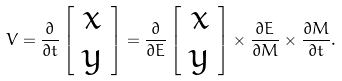<formula> <loc_0><loc_0><loc_500><loc_500>V = \frac { \partial } { \partial t } \left [ \begin{array} { c } x \\ y \end{array} \right ] = \frac { \partial } { \partial E } \left [ \begin{array} { c } x \\ y \end{array} \right ] \times \frac { \partial E } { \partial M } \times \frac { \partial M } { \partial t } .</formula> 